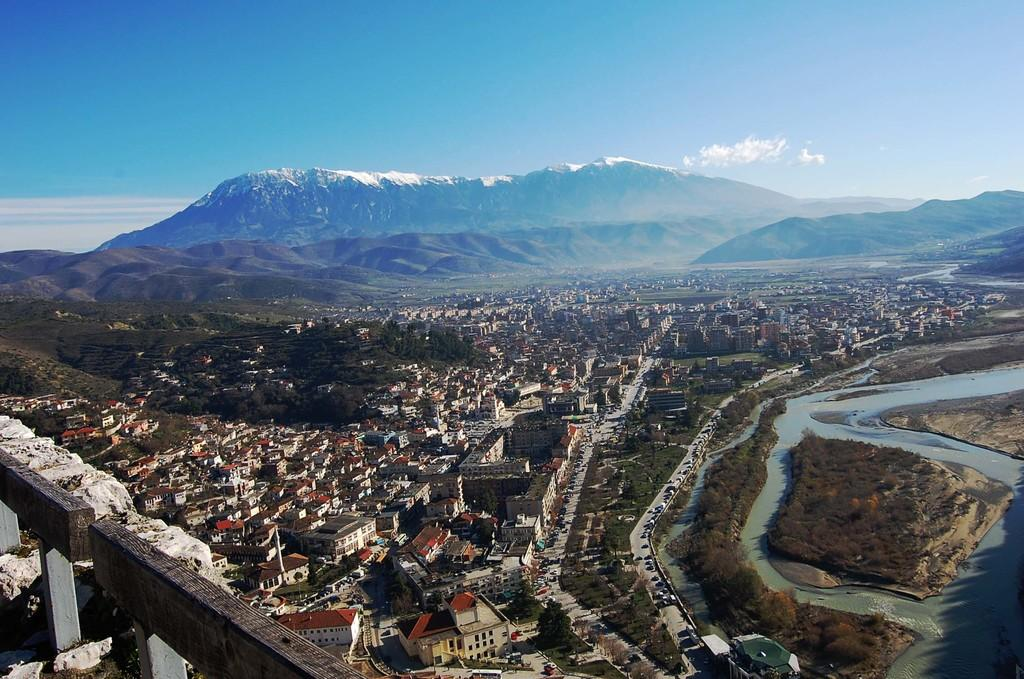What can be seen in the background of the image? In the background of the image, there is sky with clouds and hills. What type of structures are present in the image? There are buildings in the image. What other natural elements can be seen in the image? There are trees in the image. What is happening on the road in the image? There are vehicles on the road in the image. What type of sack is being used to sort the chance in the image? There is no sack, chance, or sorting activity present in the image. 